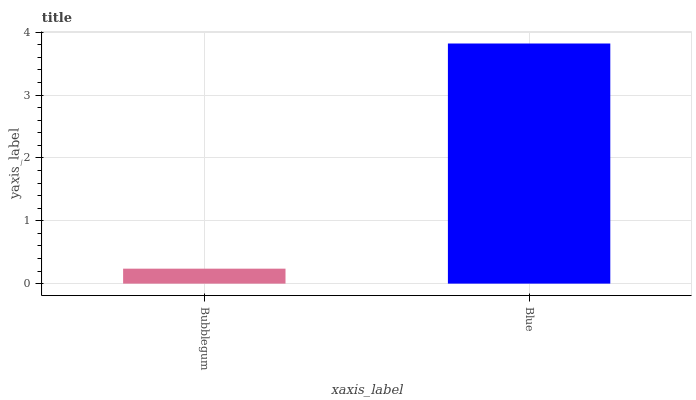Is Bubblegum the minimum?
Answer yes or no. Yes. Is Blue the maximum?
Answer yes or no. Yes. Is Blue the minimum?
Answer yes or no. No. Is Blue greater than Bubblegum?
Answer yes or no. Yes. Is Bubblegum less than Blue?
Answer yes or no. Yes. Is Bubblegum greater than Blue?
Answer yes or no. No. Is Blue less than Bubblegum?
Answer yes or no. No. Is Blue the high median?
Answer yes or no. Yes. Is Bubblegum the low median?
Answer yes or no. Yes. Is Bubblegum the high median?
Answer yes or no. No. Is Blue the low median?
Answer yes or no. No. 